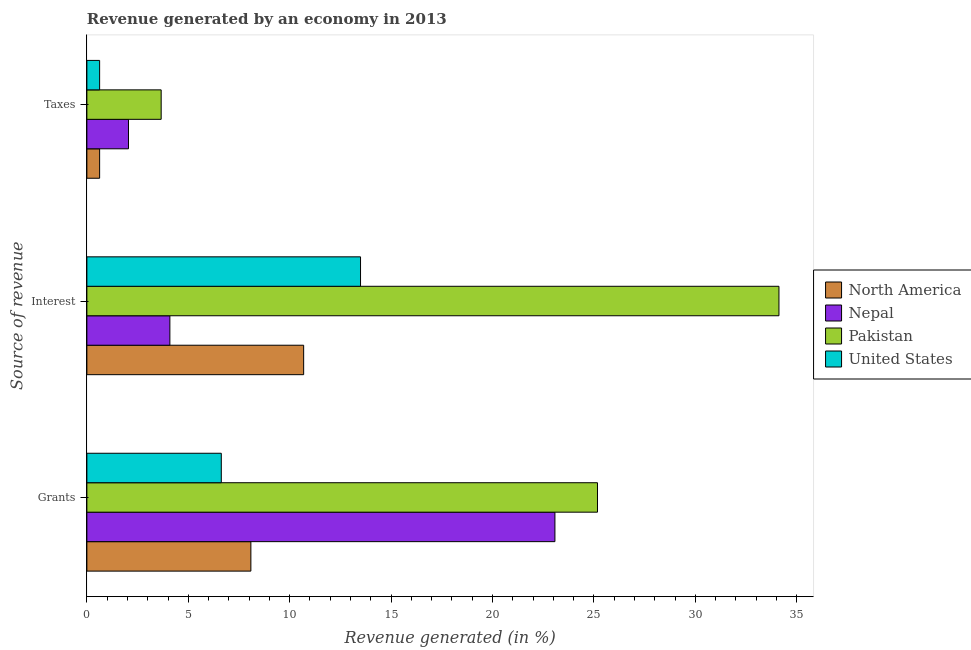Are the number of bars per tick equal to the number of legend labels?
Your response must be concise. Yes. How many bars are there on the 2nd tick from the top?
Ensure brevity in your answer.  4. What is the label of the 3rd group of bars from the top?
Keep it short and to the point. Grants. What is the percentage of revenue generated by interest in North America?
Provide a succinct answer. 10.69. Across all countries, what is the maximum percentage of revenue generated by grants?
Ensure brevity in your answer.  25.18. Across all countries, what is the minimum percentage of revenue generated by interest?
Ensure brevity in your answer.  4.09. In which country was the percentage of revenue generated by taxes maximum?
Provide a short and direct response. Pakistan. What is the total percentage of revenue generated by taxes in the graph?
Your answer should be compact. 6.97. What is the difference between the percentage of revenue generated by taxes in Nepal and that in Pakistan?
Offer a terse response. -1.61. What is the difference between the percentage of revenue generated by grants in United States and the percentage of revenue generated by taxes in Pakistan?
Provide a succinct answer. 2.96. What is the average percentage of revenue generated by grants per country?
Make the answer very short. 15.74. What is the difference between the percentage of revenue generated by interest and percentage of revenue generated by grants in North America?
Give a very brief answer. 2.6. What is the ratio of the percentage of revenue generated by interest in Nepal to that in North America?
Your answer should be compact. 0.38. What is the difference between the highest and the second highest percentage of revenue generated by grants?
Ensure brevity in your answer.  2.1. What is the difference between the highest and the lowest percentage of revenue generated by interest?
Make the answer very short. 30.03. In how many countries, is the percentage of revenue generated by grants greater than the average percentage of revenue generated by grants taken over all countries?
Ensure brevity in your answer.  2. What does the 2nd bar from the top in Grants represents?
Your answer should be compact. Pakistan. Are all the bars in the graph horizontal?
Your response must be concise. Yes. What is the difference between two consecutive major ticks on the X-axis?
Give a very brief answer. 5. Does the graph contain any zero values?
Keep it short and to the point. No. What is the title of the graph?
Keep it short and to the point. Revenue generated by an economy in 2013. Does "Libya" appear as one of the legend labels in the graph?
Offer a terse response. No. What is the label or title of the X-axis?
Your response must be concise. Revenue generated (in %). What is the label or title of the Y-axis?
Ensure brevity in your answer.  Source of revenue. What is the Revenue generated (in %) in North America in Grants?
Your answer should be compact. 8.09. What is the Revenue generated (in %) in Nepal in Grants?
Your answer should be compact. 23.08. What is the Revenue generated (in %) of Pakistan in Grants?
Provide a succinct answer. 25.18. What is the Revenue generated (in %) in United States in Grants?
Offer a very short reply. 6.63. What is the Revenue generated (in %) in North America in Interest?
Provide a short and direct response. 10.69. What is the Revenue generated (in %) in Nepal in Interest?
Your response must be concise. 4.09. What is the Revenue generated (in %) of Pakistan in Interest?
Make the answer very short. 34.12. What is the Revenue generated (in %) in United States in Interest?
Offer a terse response. 13.49. What is the Revenue generated (in %) of North America in Taxes?
Your response must be concise. 0.63. What is the Revenue generated (in %) of Nepal in Taxes?
Offer a terse response. 2.05. What is the Revenue generated (in %) in Pakistan in Taxes?
Offer a very short reply. 3.66. What is the Revenue generated (in %) of United States in Taxes?
Your answer should be compact. 0.63. Across all Source of revenue, what is the maximum Revenue generated (in %) of North America?
Your answer should be compact. 10.69. Across all Source of revenue, what is the maximum Revenue generated (in %) in Nepal?
Ensure brevity in your answer.  23.08. Across all Source of revenue, what is the maximum Revenue generated (in %) in Pakistan?
Make the answer very short. 34.12. Across all Source of revenue, what is the maximum Revenue generated (in %) of United States?
Keep it short and to the point. 13.49. Across all Source of revenue, what is the minimum Revenue generated (in %) in North America?
Give a very brief answer. 0.63. Across all Source of revenue, what is the minimum Revenue generated (in %) in Nepal?
Your answer should be very brief. 2.05. Across all Source of revenue, what is the minimum Revenue generated (in %) in Pakistan?
Give a very brief answer. 3.66. Across all Source of revenue, what is the minimum Revenue generated (in %) in United States?
Provide a short and direct response. 0.63. What is the total Revenue generated (in %) of North America in the graph?
Your answer should be compact. 19.4. What is the total Revenue generated (in %) in Nepal in the graph?
Offer a terse response. 29.22. What is the total Revenue generated (in %) in Pakistan in the graph?
Make the answer very short. 62.96. What is the total Revenue generated (in %) in United States in the graph?
Your response must be concise. 20.75. What is the difference between the Revenue generated (in %) in North America in Grants and that in Interest?
Provide a short and direct response. -2.6. What is the difference between the Revenue generated (in %) of Nepal in Grants and that in Interest?
Your response must be concise. 18.99. What is the difference between the Revenue generated (in %) of Pakistan in Grants and that in Interest?
Ensure brevity in your answer.  -8.95. What is the difference between the Revenue generated (in %) of United States in Grants and that in Interest?
Give a very brief answer. -6.87. What is the difference between the Revenue generated (in %) in North America in Grants and that in Taxes?
Make the answer very short. 7.46. What is the difference between the Revenue generated (in %) in Nepal in Grants and that in Taxes?
Make the answer very short. 21.03. What is the difference between the Revenue generated (in %) of Pakistan in Grants and that in Taxes?
Your answer should be very brief. 21.51. What is the difference between the Revenue generated (in %) in United States in Grants and that in Taxes?
Your answer should be compact. 6. What is the difference between the Revenue generated (in %) in North America in Interest and that in Taxes?
Provide a short and direct response. 10.06. What is the difference between the Revenue generated (in %) in Nepal in Interest and that in Taxes?
Offer a terse response. 2.04. What is the difference between the Revenue generated (in %) of Pakistan in Interest and that in Taxes?
Your response must be concise. 30.46. What is the difference between the Revenue generated (in %) of United States in Interest and that in Taxes?
Offer a very short reply. 12.86. What is the difference between the Revenue generated (in %) of North America in Grants and the Revenue generated (in %) of Nepal in Interest?
Provide a short and direct response. 3.99. What is the difference between the Revenue generated (in %) in North America in Grants and the Revenue generated (in %) in Pakistan in Interest?
Make the answer very short. -26.04. What is the difference between the Revenue generated (in %) in North America in Grants and the Revenue generated (in %) in United States in Interest?
Provide a short and direct response. -5.41. What is the difference between the Revenue generated (in %) of Nepal in Grants and the Revenue generated (in %) of Pakistan in Interest?
Provide a succinct answer. -11.05. What is the difference between the Revenue generated (in %) of Nepal in Grants and the Revenue generated (in %) of United States in Interest?
Provide a short and direct response. 9.58. What is the difference between the Revenue generated (in %) of Pakistan in Grants and the Revenue generated (in %) of United States in Interest?
Provide a short and direct response. 11.68. What is the difference between the Revenue generated (in %) of North America in Grants and the Revenue generated (in %) of Nepal in Taxes?
Make the answer very short. 6.03. What is the difference between the Revenue generated (in %) in North America in Grants and the Revenue generated (in %) in Pakistan in Taxes?
Give a very brief answer. 4.42. What is the difference between the Revenue generated (in %) in North America in Grants and the Revenue generated (in %) in United States in Taxes?
Offer a very short reply. 7.46. What is the difference between the Revenue generated (in %) of Nepal in Grants and the Revenue generated (in %) of Pakistan in Taxes?
Ensure brevity in your answer.  19.41. What is the difference between the Revenue generated (in %) in Nepal in Grants and the Revenue generated (in %) in United States in Taxes?
Give a very brief answer. 22.45. What is the difference between the Revenue generated (in %) of Pakistan in Grants and the Revenue generated (in %) of United States in Taxes?
Provide a short and direct response. 24.55. What is the difference between the Revenue generated (in %) in North America in Interest and the Revenue generated (in %) in Nepal in Taxes?
Offer a very short reply. 8.64. What is the difference between the Revenue generated (in %) in North America in Interest and the Revenue generated (in %) in Pakistan in Taxes?
Your answer should be very brief. 7.03. What is the difference between the Revenue generated (in %) in North America in Interest and the Revenue generated (in %) in United States in Taxes?
Your answer should be compact. 10.06. What is the difference between the Revenue generated (in %) of Nepal in Interest and the Revenue generated (in %) of Pakistan in Taxes?
Ensure brevity in your answer.  0.43. What is the difference between the Revenue generated (in %) in Nepal in Interest and the Revenue generated (in %) in United States in Taxes?
Provide a short and direct response. 3.46. What is the difference between the Revenue generated (in %) in Pakistan in Interest and the Revenue generated (in %) in United States in Taxes?
Your answer should be very brief. 33.49. What is the average Revenue generated (in %) of North America per Source of revenue?
Give a very brief answer. 6.47. What is the average Revenue generated (in %) of Nepal per Source of revenue?
Keep it short and to the point. 9.74. What is the average Revenue generated (in %) of Pakistan per Source of revenue?
Give a very brief answer. 20.99. What is the average Revenue generated (in %) of United States per Source of revenue?
Keep it short and to the point. 6.92. What is the difference between the Revenue generated (in %) in North America and Revenue generated (in %) in Nepal in Grants?
Offer a terse response. -14.99. What is the difference between the Revenue generated (in %) of North America and Revenue generated (in %) of Pakistan in Grants?
Your answer should be compact. -17.09. What is the difference between the Revenue generated (in %) of North America and Revenue generated (in %) of United States in Grants?
Offer a very short reply. 1.46. What is the difference between the Revenue generated (in %) in Nepal and Revenue generated (in %) in Pakistan in Grants?
Offer a very short reply. -2.1. What is the difference between the Revenue generated (in %) of Nepal and Revenue generated (in %) of United States in Grants?
Make the answer very short. 16.45. What is the difference between the Revenue generated (in %) of Pakistan and Revenue generated (in %) of United States in Grants?
Provide a short and direct response. 18.55. What is the difference between the Revenue generated (in %) of North America and Revenue generated (in %) of Nepal in Interest?
Your answer should be very brief. 6.6. What is the difference between the Revenue generated (in %) in North America and Revenue generated (in %) in Pakistan in Interest?
Your answer should be compact. -23.43. What is the difference between the Revenue generated (in %) in North America and Revenue generated (in %) in United States in Interest?
Provide a short and direct response. -2.8. What is the difference between the Revenue generated (in %) in Nepal and Revenue generated (in %) in Pakistan in Interest?
Your response must be concise. -30.03. What is the difference between the Revenue generated (in %) in Nepal and Revenue generated (in %) in United States in Interest?
Offer a very short reply. -9.4. What is the difference between the Revenue generated (in %) in Pakistan and Revenue generated (in %) in United States in Interest?
Make the answer very short. 20.63. What is the difference between the Revenue generated (in %) of North America and Revenue generated (in %) of Nepal in Taxes?
Offer a terse response. -1.42. What is the difference between the Revenue generated (in %) of North America and Revenue generated (in %) of Pakistan in Taxes?
Make the answer very short. -3.03. What is the difference between the Revenue generated (in %) of North America and Revenue generated (in %) of United States in Taxes?
Keep it short and to the point. 0. What is the difference between the Revenue generated (in %) in Nepal and Revenue generated (in %) in Pakistan in Taxes?
Offer a very short reply. -1.61. What is the difference between the Revenue generated (in %) of Nepal and Revenue generated (in %) of United States in Taxes?
Provide a succinct answer. 1.42. What is the difference between the Revenue generated (in %) in Pakistan and Revenue generated (in %) in United States in Taxes?
Your answer should be compact. 3.03. What is the ratio of the Revenue generated (in %) of North America in Grants to that in Interest?
Ensure brevity in your answer.  0.76. What is the ratio of the Revenue generated (in %) in Nepal in Grants to that in Interest?
Offer a terse response. 5.64. What is the ratio of the Revenue generated (in %) in Pakistan in Grants to that in Interest?
Give a very brief answer. 0.74. What is the ratio of the Revenue generated (in %) in United States in Grants to that in Interest?
Give a very brief answer. 0.49. What is the ratio of the Revenue generated (in %) in North America in Grants to that in Taxes?
Your answer should be very brief. 12.86. What is the ratio of the Revenue generated (in %) of Nepal in Grants to that in Taxes?
Keep it short and to the point. 11.25. What is the ratio of the Revenue generated (in %) of Pakistan in Grants to that in Taxes?
Give a very brief answer. 6.87. What is the ratio of the Revenue generated (in %) of United States in Grants to that in Taxes?
Keep it short and to the point. 10.54. What is the ratio of the Revenue generated (in %) of North America in Interest to that in Taxes?
Offer a terse response. 17. What is the ratio of the Revenue generated (in %) in Nepal in Interest to that in Taxes?
Ensure brevity in your answer.  1.99. What is the ratio of the Revenue generated (in %) in Pakistan in Interest to that in Taxes?
Provide a short and direct response. 9.31. What is the ratio of the Revenue generated (in %) in United States in Interest to that in Taxes?
Provide a short and direct response. 21.46. What is the difference between the highest and the second highest Revenue generated (in %) in North America?
Give a very brief answer. 2.6. What is the difference between the highest and the second highest Revenue generated (in %) of Nepal?
Provide a short and direct response. 18.99. What is the difference between the highest and the second highest Revenue generated (in %) of Pakistan?
Make the answer very short. 8.95. What is the difference between the highest and the second highest Revenue generated (in %) of United States?
Make the answer very short. 6.87. What is the difference between the highest and the lowest Revenue generated (in %) of North America?
Your answer should be very brief. 10.06. What is the difference between the highest and the lowest Revenue generated (in %) of Nepal?
Offer a terse response. 21.03. What is the difference between the highest and the lowest Revenue generated (in %) of Pakistan?
Make the answer very short. 30.46. What is the difference between the highest and the lowest Revenue generated (in %) of United States?
Ensure brevity in your answer.  12.86. 